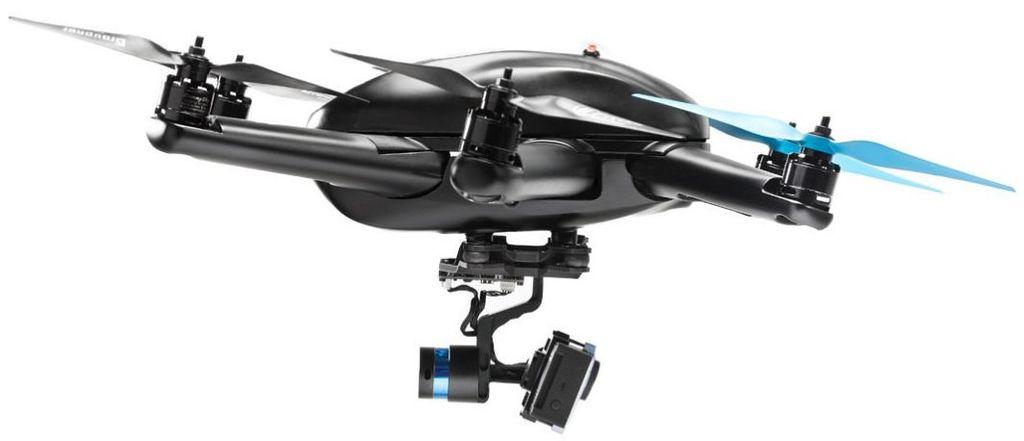What is the color of the machine in the image? The machine in the image is black in color. What color is the background of the image? The background of the image is white in color. How many bees can be seen flying around the machine in the image? There are no bees present in the image. What type of beef is being cooked on the machine in the image? There is no beef or cooking activity present in the image. 